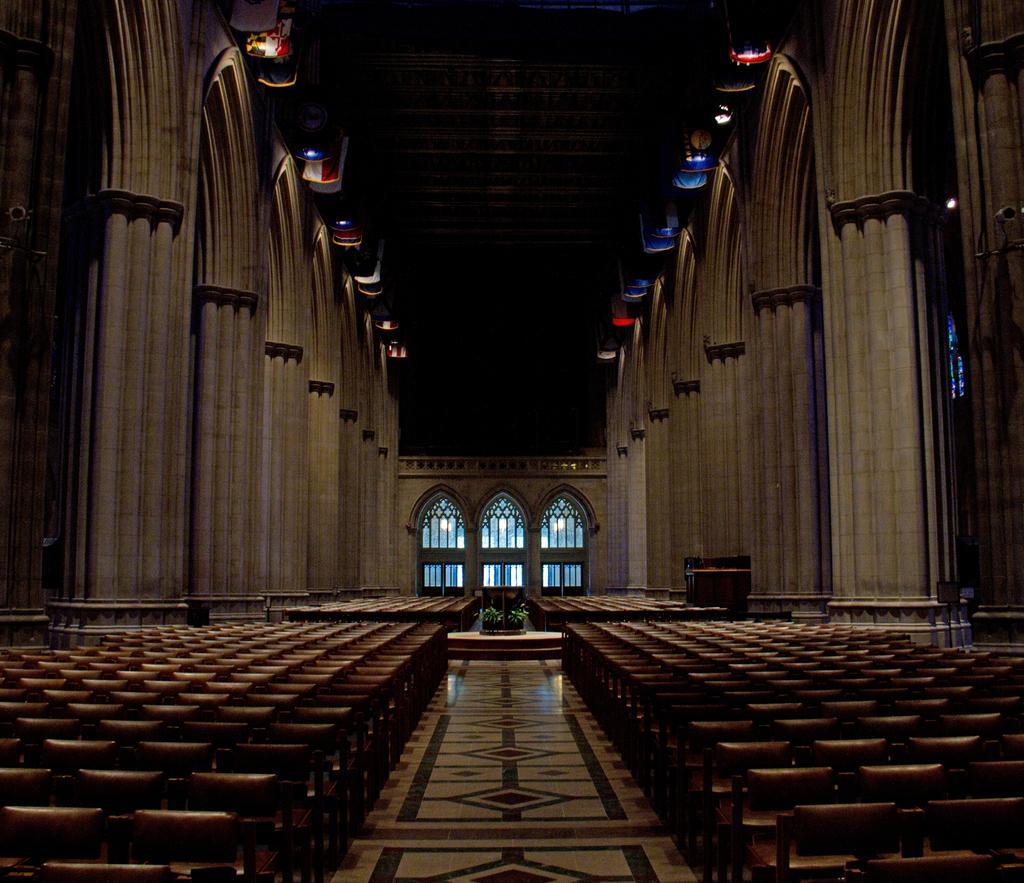How would you summarize this image in a sentence or two? This picture is an inside view of a building. In this picture we can see pillars, lights, wall, door, chairs, floor, speakers. At the top of the image there is a roof. 